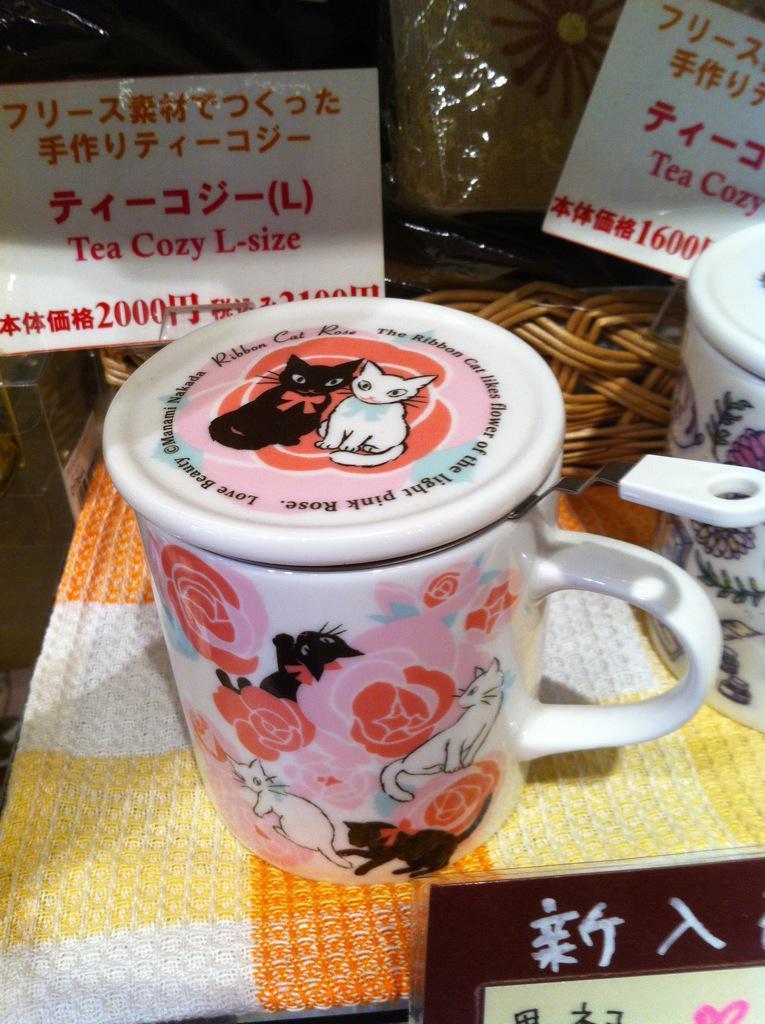In one or two sentences, can you explain what this image depicts? In this picture there are two floral cups on the table and there is a basket and there are stickers on the cover. At the bottom there is a cloth and there is a board and there is a text on the board and on the stickers. 